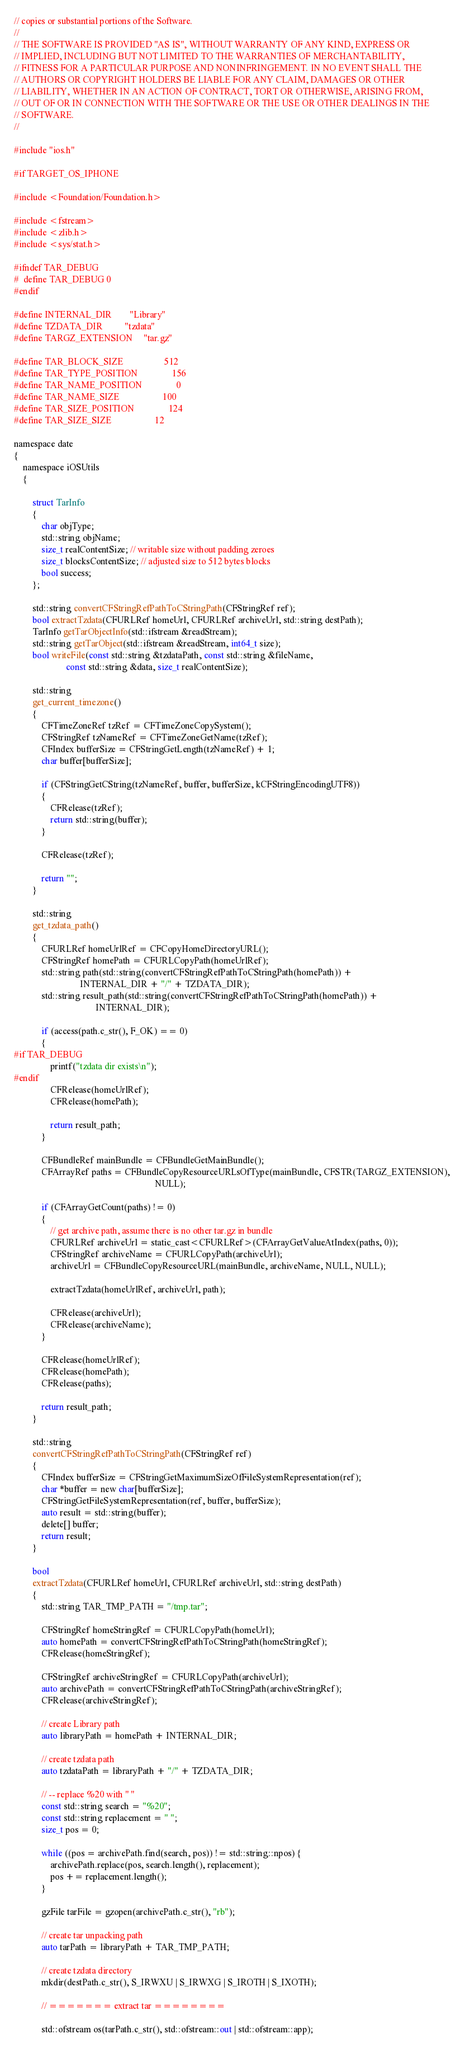Convert code to text. <code><loc_0><loc_0><loc_500><loc_500><_ObjectiveC_>// copies or substantial portions of the Software.
//
// THE SOFTWARE IS PROVIDED "AS IS", WITHOUT WARRANTY OF ANY KIND, EXPRESS OR
// IMPLIED, INCLUDING BUT NOT LIMITED TO THE WARRANTIES OF MERCHANTABILITY,
// FITNESS FOR A PARTICULAR PURPOSE AND NONINFRINGEMENT. IN NO EVENT SHALL THE
// AUTHORS OR COPYRIGHT HOLDERS BE LIABLE FOR ANY CLAIM, DAMAGES OR OTHER
// LIABILITY, WHETHER IN AN ACTION OF CONTRACT, TORT OR OTHERWISE, ARISING FROM,
// OUT OF OR IN CONNECTION WITH THE SOFTWARE OR THE USE OR OTHER DEALINGS IN THE
// SOFTWARE.
//

#include "ios.h"

#if TARGET_OS_IPHONE

#include <Foundation/Foundation.h>

#include <fstream>
#include <zlib.h>
#include <sys/stat.h>

#ifndef TAR_DEBUG
#  define TAR_DEBUG 0
#endif

#define INTERNAL_DIR        "Library"
#define TZDATA_DIR          "tzdata"
#define TARGZ_EXTENSION     "tar.gz"

#define TAR_BLOCK_SIZE                  512
#define TAR_TYPE_POSITION               156
#define TAR_NAME_POSITION               0
#define TAR_NAME_SIZE                   100
#define TAR_SIZE_POSITION               124
#define TAR_SIZE_SIZE                   12

namespace date
{
    namespace iOSUtils
    {
        
        struct TarInfo
        {
            char objType;
            std::string objName;
            size_t realContentSize; // writable size without padding zeroes
            size_t blocksContentSize; // adjusted size to 512 bytes blocks
            bool success;
        };
        
        std::string convertCFStringRefPathToCStringPath(CFStringRef ref);
        bool extractTzdata(CFURLRef homeUrl, CFURLRef archiveUrl, std::string destPath);
        TarInfo getTarObjectInfo(std::ifstream &readStream);
        std::string getTarObject(std::ifstream &readStream, int64_t size);
        bool writeFile(const std::string &tzdataPath, const std::string &fileName,
                       const std::string &data, size_t realContentSize);
        
        std::string
        get_current_timezone()
        {
            CFTimeZoneRef tzRef = CFTimeZoneCopySystem();
            CFStringRef tzNameRef = CFTimeZoneGetName(tzRef);
            CFIndex bufferSize = CFStringGetLength(tzNameRef) + 1;
            char buffer[bufferSize];
            
            if (CFStringGetCString(tzNameRef, buffer, bufferSize, kCFStringEncodingUTF8))
            {
                CFRelease(tzRef);
                return std::string(buffer);
            }
            
            CFRelease(tzRef);
            
            return "";
        }
        
        std::string
        get_tzdata_path()
        {
            CFURLRef homeUrlRef = CFCopyHomeDirectoryURL();
            CFStringRef homePath = CFURLCopyPath(homeUrlRef);
            std::string path(std::string(convertCFStringRefPathToCStringPath(homePath)) +
                             INTERNAL_DIR + "/" + TZDATA_DIR);
            std::string result_path(std::string(convertCFStringRefPathToCStringPath(homePath)) +
                                    INTERNAL_DIR);
            
            if (access(path.c_str(), F_OK) == 0)
            {
#if TAR_DEBUG
                printf("tzdata dir exists\n");
#endif
                CFRelease(homeUrlRef);
                CFRelease(homePath);
                
                return result_path;
            }
            
            CFBundleRef mainBundle = CFBundleGetMainBundle();
            CFArrayRef paths = CFBundleCopyResourceURLsOfType(mainBundle, CFSTR(TARGZ_EXTENSION),
                                                              NULL);
            
            if (CFArrayGetCount(paths) != 0)
            {
                // get archive path, assume there is no other tar.gz in bundle
                CFURLRef archiveUrl = static_cast<CFURLRef>(CFArrayGetValueAtIndex(paths, 0));
                CFStringRef archiveName = CFURLCopyPath(archiveUrl);
                archiveUrl = CFBundleCopyResourceURL(mainBundle, archiveName, NULL, NULL);
                
                extractTzdata(homeUrlRef, archiveUrl, path);
                
                CFRelease(archiveUrl);
                CFRelease(archiveName);
            }
            
            CFRelease(homeUrlRef);
            CFRelease(homePath);
            CFRelease(paths);
            
            return result_path;
        }
        
        std::string
        convertCFStringRefPathToCStringPath(CFStringRef ref)
        {
            CFIndex bufferSize = CFStringGetMaximumSizeOfFileSystemRepresentation(ref);
            char *buffer = new char[bufferSize];
            CFStringGetFileSystemRepresentation(ref, buffer, bufferSize);
            auto result = std::string(buffer);
            delete[] buffer;
            return result;
        }
        
        bool
        extractTzdata(CFURLRef homeUrl, CFURLRef archiveUrl, std::string destPath)
        {
            std::string TAR_TMP_PATH = "/tmp.tar";
            
            CFStringRef homeStringRef = CFURLCopyPath(homeUrl);
            auto homePath = convertCFStringRefPathToCStringPath(homeStringRef);
            CFRelease(homeStringRef);
            
            CFStringRef archiveStringRef = CFURLCopyPath(archiveUrl);
            auto archivePath = convertCFStringRefPathToCStringPath(archiveStringRef);
            CFRelease(archiveStringRef);
            
            // create Library path
            auto libraryPath = homePath + INTERNAL_DIR;
            
            // create tzdata path
            auto tzdataPath = libraryPath + "/" + TZDATA_DIR;
            
            // -- replace %20 with " "
            const std::string search = "%20";
            const std::string replacement = " ";
            size_t pos = 0;
            
            while ((pos = archivePath.find(search, pos)) != std::string::npos) {
                archivePath.replace(pos, search.length(), replacement);
                pos += replacement.length();
            }
            
            gzFile tarFile = gzopen(archivePath.c_str(), "rb");
            
            // create tar unpacking path
            auto tarPath = libraryPath + TAR_TMP_PATH;
            
            // create tzdata directory
            mkdir(destPath.c_str(), S_IRWXU | S_IRWXG | S_IROTH | S_IXOTH);
            
            // ======= extract tar ========
            
            std::ofstream os(tarPath.c_str(), std::ofstream::out | std::ofstream::app);</code> 